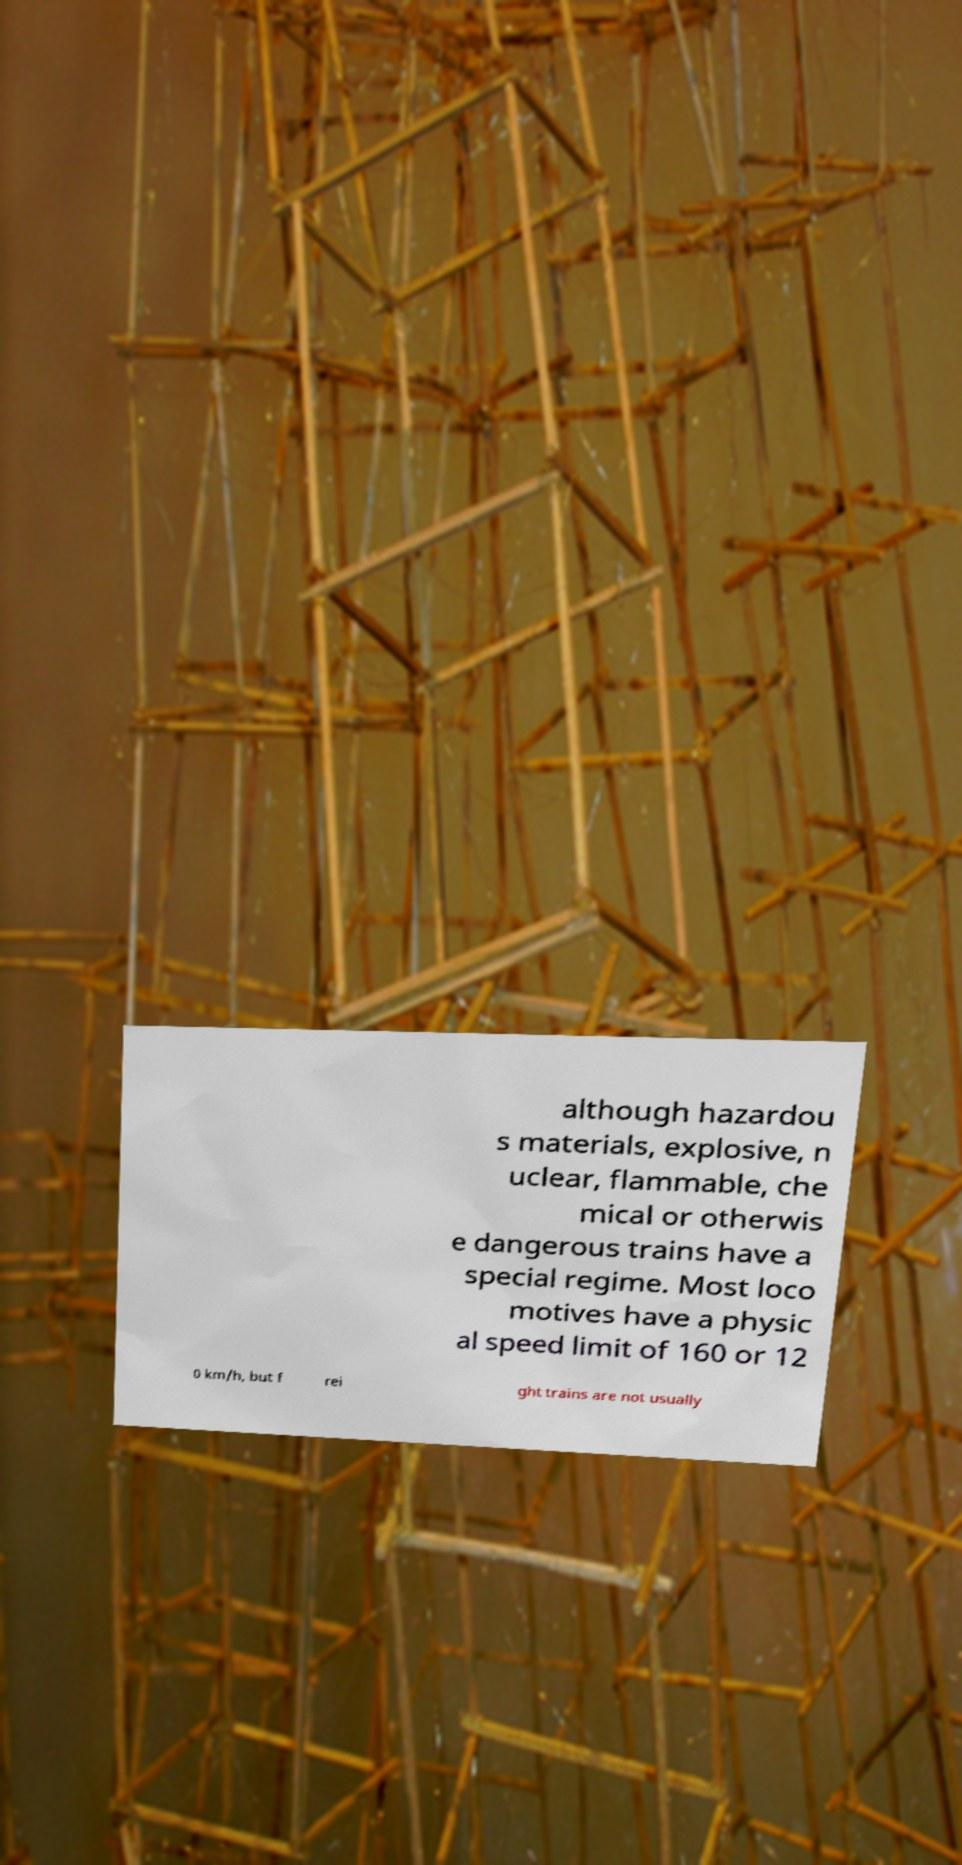For documentation purposes, I need the text within this image transcribed. Could you provide that? although hazardou s materials, explosive, n uclear, flammable, che mical or otherwis e dangerous trains have a special regime. Most loco motives have a physic al speed limit of 160 or 12 0 km/h, but f rei ght trains are not usually 